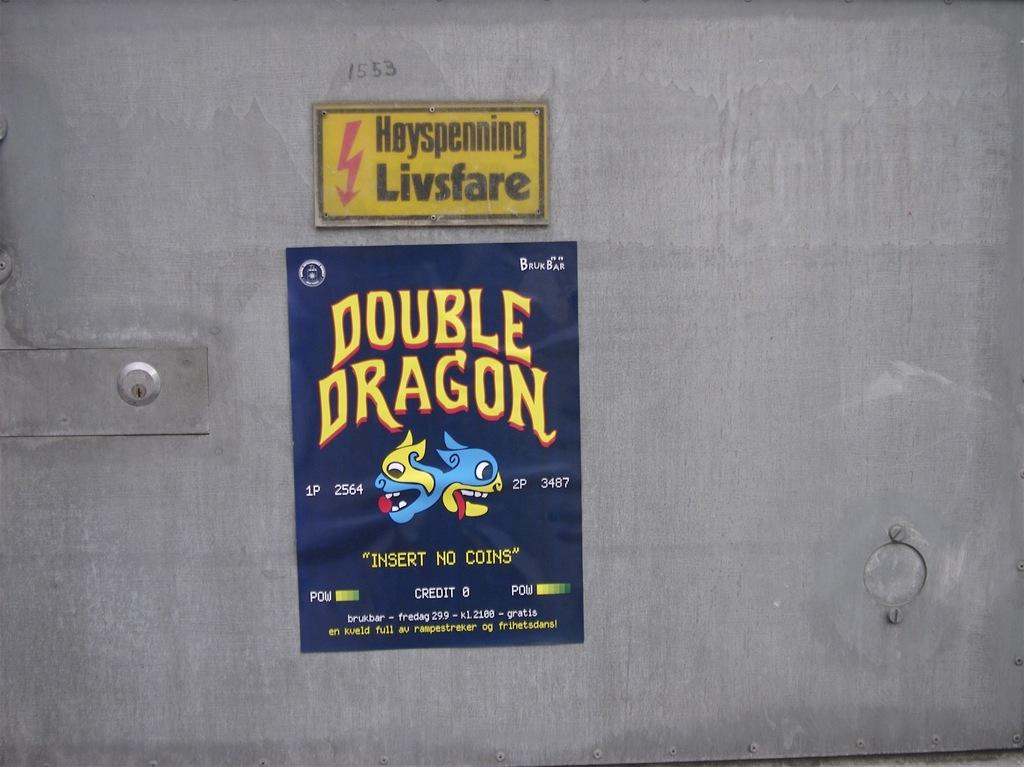<image>
Give a short and clear explanation of the subsequent image. Stickers on metal door, one is in a foreign language and another says Double Dragon insert no coins. 